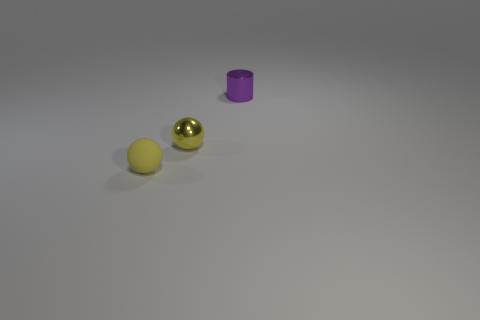Is there anything else that is the same shape as the tiny purple metal object?
Give a very brief answer. No. There is a tiny sphere that is the same color as the matte thing; what material is it?
Your answer should be compact. Metal. What number of other objects are the same material as the cylinder?
Ensure brevity in your answer.  1. Is the shape of the tiny yellow matte thing the same as the shiny object on the right side of the yellow metal ball?
Provide a short and direct response. No. What is the shape of the yellow thing that is the same material as the purple cylinder?
Your response must be concise. Sphere. Are there more yellow metal objects that are in front of the cylinder than yellow matte things in front of the small yellow rubber object?
Ensure brevity in your answer.  Yes. What number of things are blue metal cylinders or purple cylinders?
Your answer should be compact. 1. What number of other things are the same color as the matte sphere?
Ensure brevity in your answer.  1. There is a yellow rubber thing that is the same size as the purple thing; what shape is it?
Your answer should be compact. Sphere. There is a sphere to the right of the rubber ball; what color is it?
Your answer should be very brief. Yellow. 